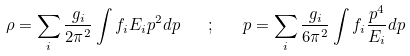<formula> <loc_0><loc_0><loc_500><loc_500>\rho = \sum _ { i } \frac { g _ { i } } { 2 \pi ^ { 2 } } \int f _ { i } { E } _ { i } p ^ { 2 } d p \quad ; \quad p = \sum _ { i } \frac { g _ { i } } { 6 \pi ^ { 2 } } \int f _ { i } \frac { p ^ { 4 } } { { E } _ { i } } d p \</formula> 